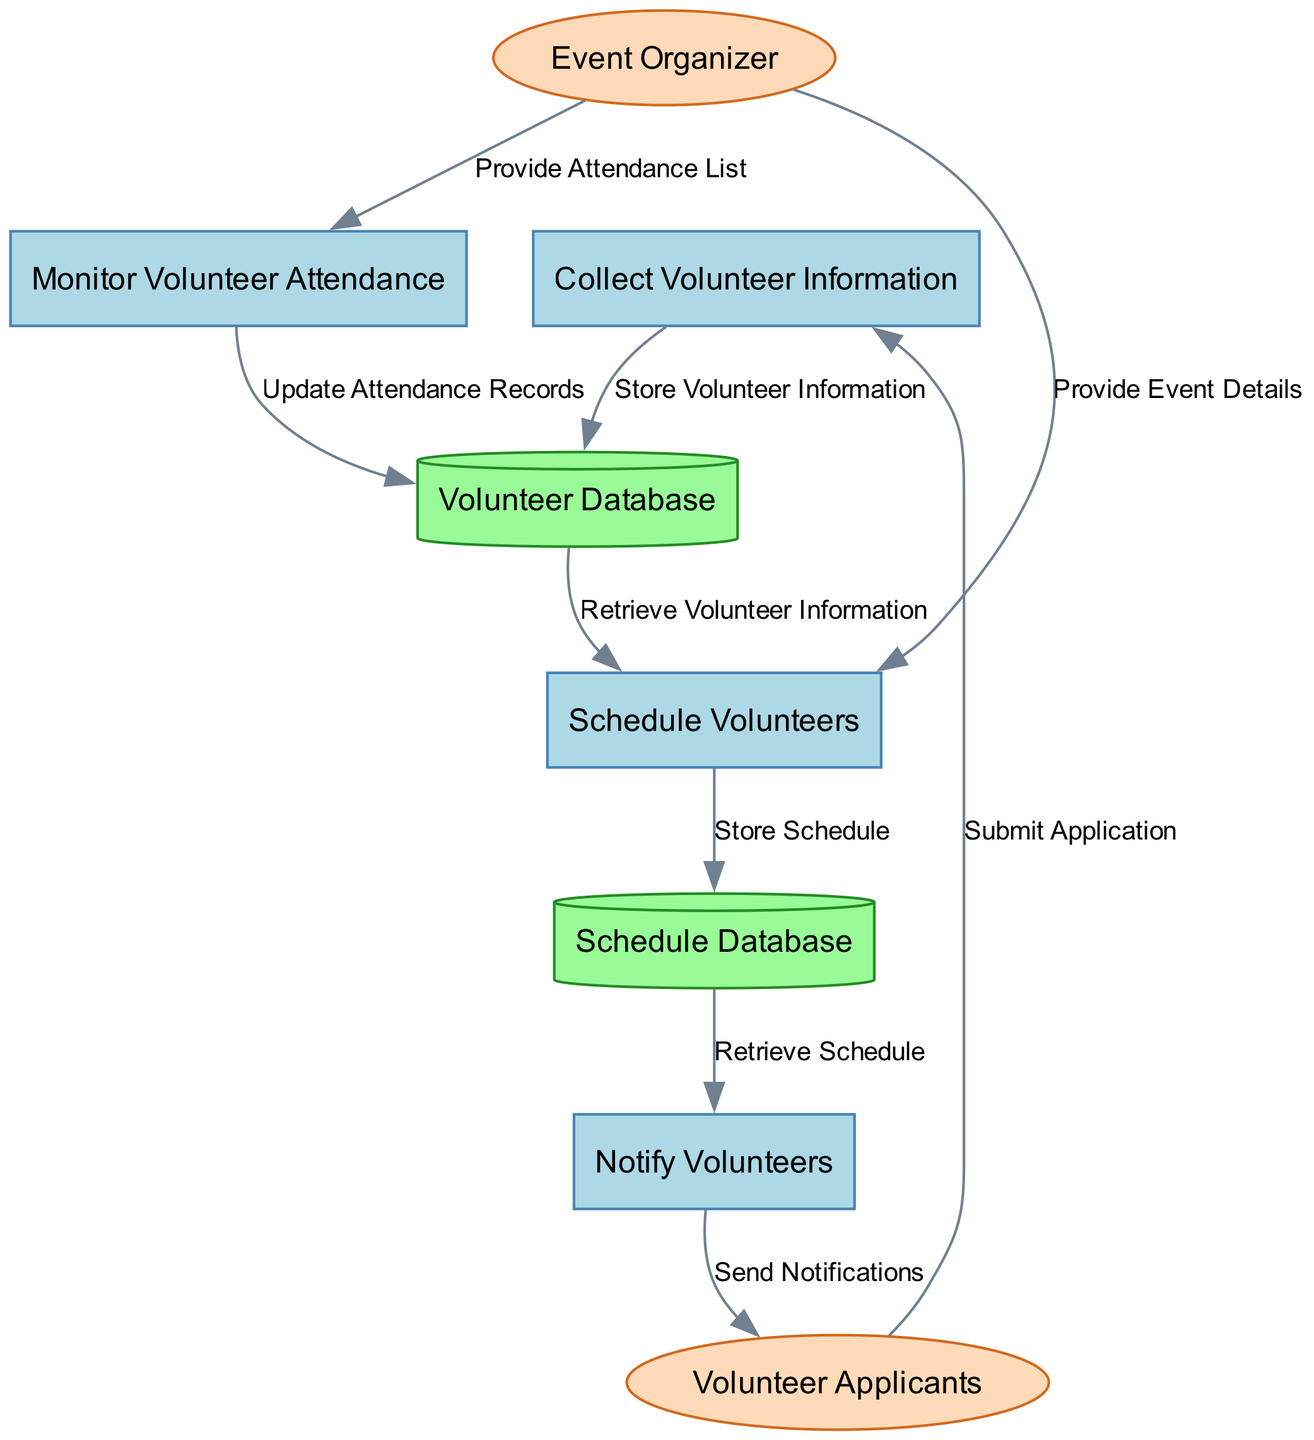What is the first process in the diagram? The first process is "Collect Volunteer Information," which is the topmost node representing the initial action in the volunteer coordination workflow.
Answer: Collect Volunteer Information How many data stores are in the diagram? There are two data stores in the diagram: "Volunteer Database" and "Schedule Database." Counting each unique data store leads to the total of two.
Answer: 2 Who submits the application? The external entity "Volunteer Applicants" submits the application to the first process, as indicated by the data flow labeled "Submit Application."
Answer: Volunteer Applicants What is the last process in the diagram? The last process is "Monitor Volunteer Attendance," which is the final step before updating records and relates to checking attendance of volunteers.
Answer: Monitor Volunteer Attendance What does the "Notify Volunteers" process send? The "Notify Volunteers" process sends "Send Notifications" to the external entity "Volunteer Applicants," indicating the process involves communication with applicants.
Answer: Send Notifications What action does the "Schedule Volunteers" process perform with the schedule data store? The "Schedule Volunteers" process stores the schedule in the "Schedule Database," as shown by the data flow labeled "Store Schedule."
Answer: Store Schedule Which external entity provides event details to the scheduling process? The external entity "Event Organizer" provides event details to the "Schedule Volunteers" process, facilitating the creation of the schedule for the volunteers.
Answer: Event Organizer What is updated during the "Monitor Volunteer Attendance" process? During the "Monitor Volunteer Attendance" process, the "Attendance Records" in the "Volunteer Database" are updated based on the information gathered.
Answer: Attendance Records What type of diagram is represented here? The diagram represents a "Data Flow Diagram," which visually depicts the processes, data stores, and data flows in the volunteer coordination system.
Answer: Data Flow Diagram 